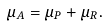<formula> <loc_0><loc_0><loc_500><loc_500>\mu _ { A } = \mu _ { P } + \mu _ { R } .</formula> 